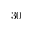Convert formula to latex. <formula><loc_0><loc_0><loc_500><loc_500>3 0</formula> 